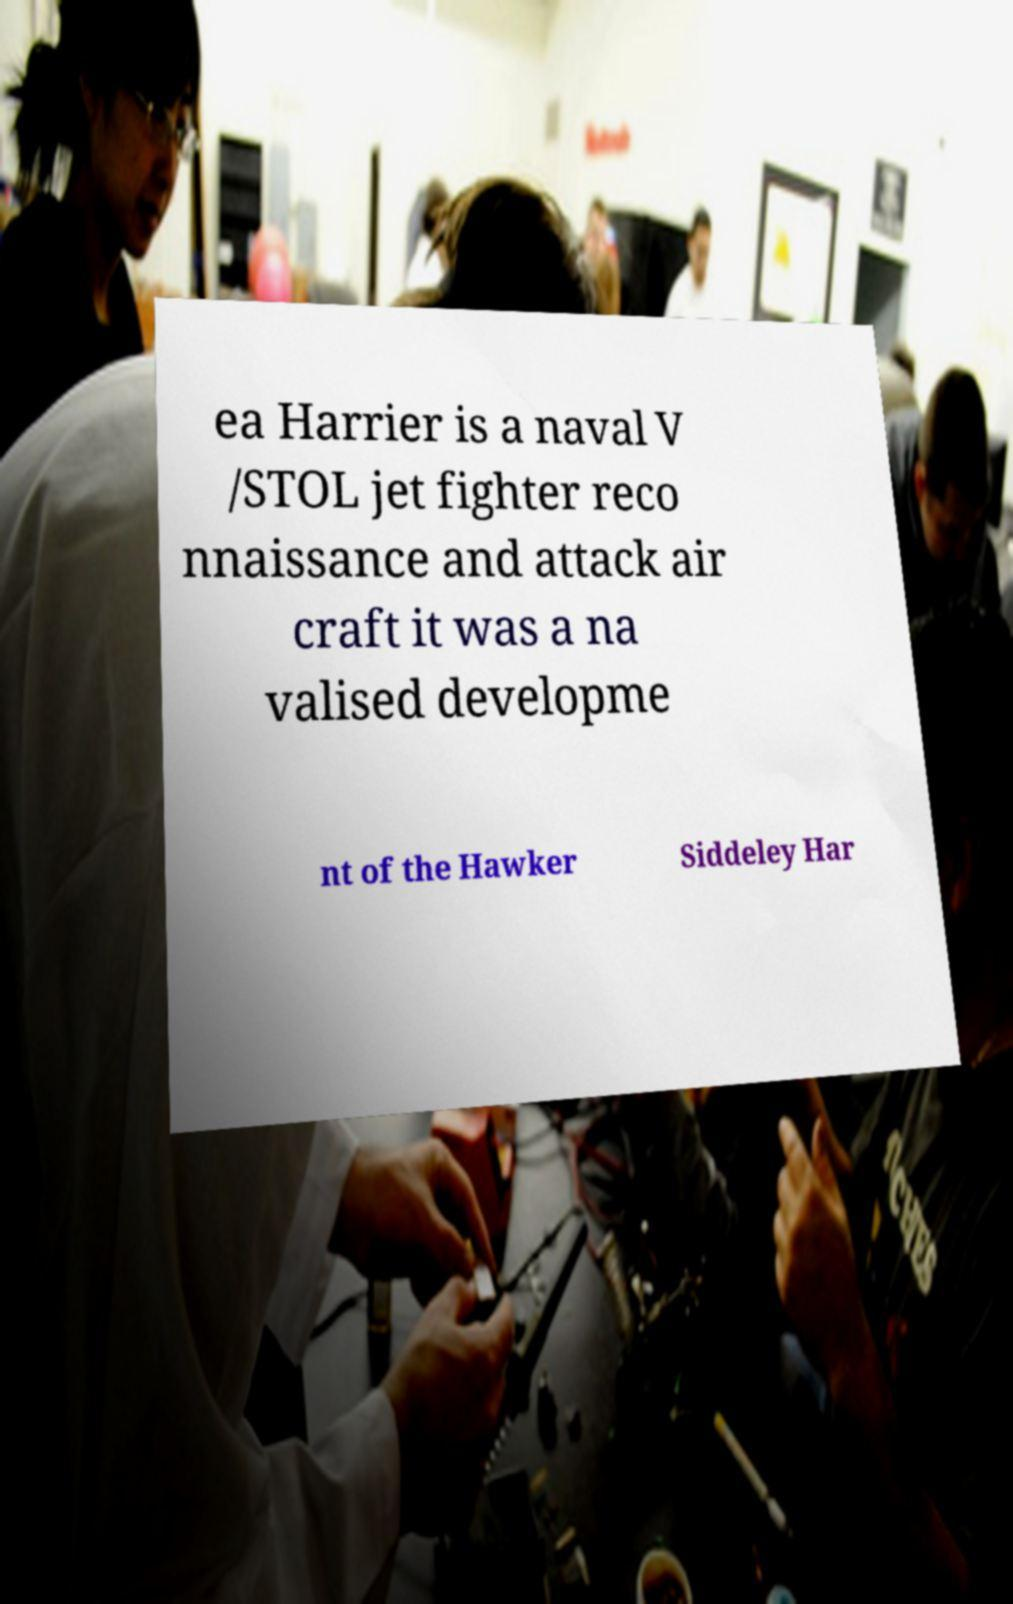Could you extract and type out the text from this image? ea Harrier is a naval V /STOL jet fighter reco nnaissance and attack air craft it was a na valised developme nt of the Hawker Siddeley Har 